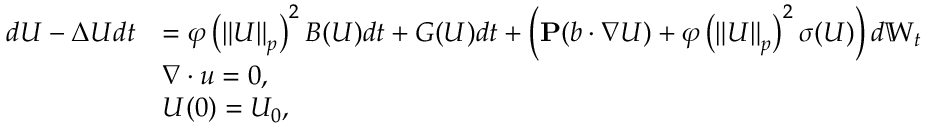<formula> <loc_0><loc_0><loc_500><loc_500>\begin{array} { r l } { d U - \Delta U d t } & { = \varphi \left ( \left \| U \right \| _ { p } \right ) ^ { 2 } B ( U ) d t + G ( U ) d t + \left ( P ( b \cdot \nabla U ) + \varphi \left ( \left \| U \right \| _ { p } \right ) ^ { 2 } \sigma ( U ) \right ) d \mathbb { W } _ { t } } \\ & { \nabla \cdot u = 0 , } \\ & { U ( 0 ) = U _ { 0 } , } \end{array}</formula> 